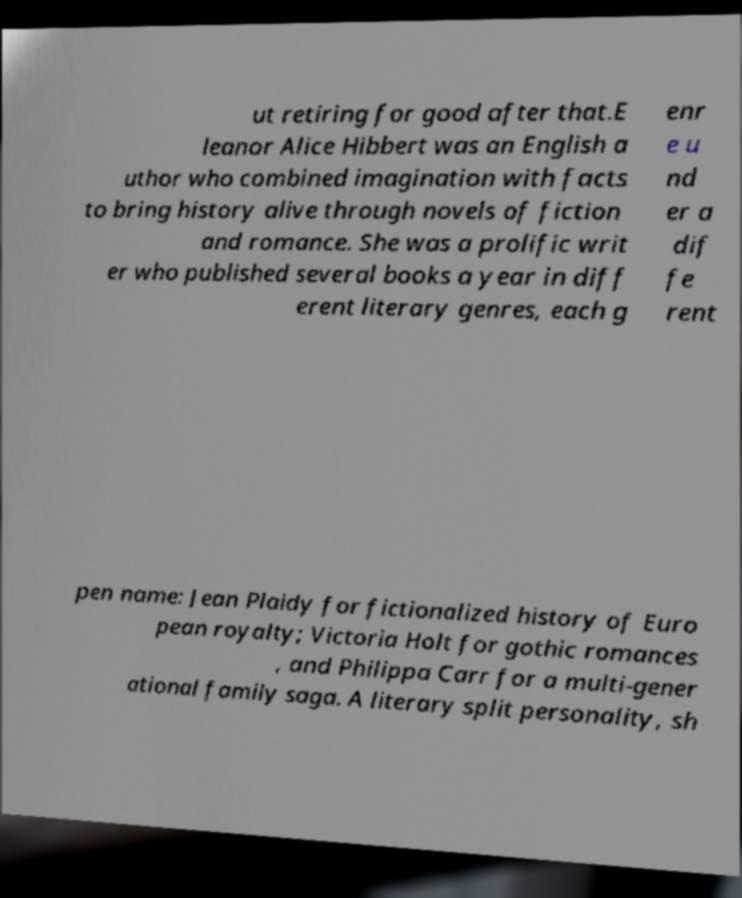For documentation purposes, I need the text within this image transcribed. Could you provide that? ut retiring for good after that.E leanor Alice Hibbert was an English a uthor who combined imagination with facts to bring history alive through novels of fiction and romance. She was a prolific writ er who published several books a year in diff erent literary genres, each g enr e u nd er a dif fe rent pen name: Jean Plaidy for fictionalized history of Euro pean royalty; Victoria Holt for gothic romances , and Philippa Carr for a multi-gener ational family saga. A literary split personality, sh 